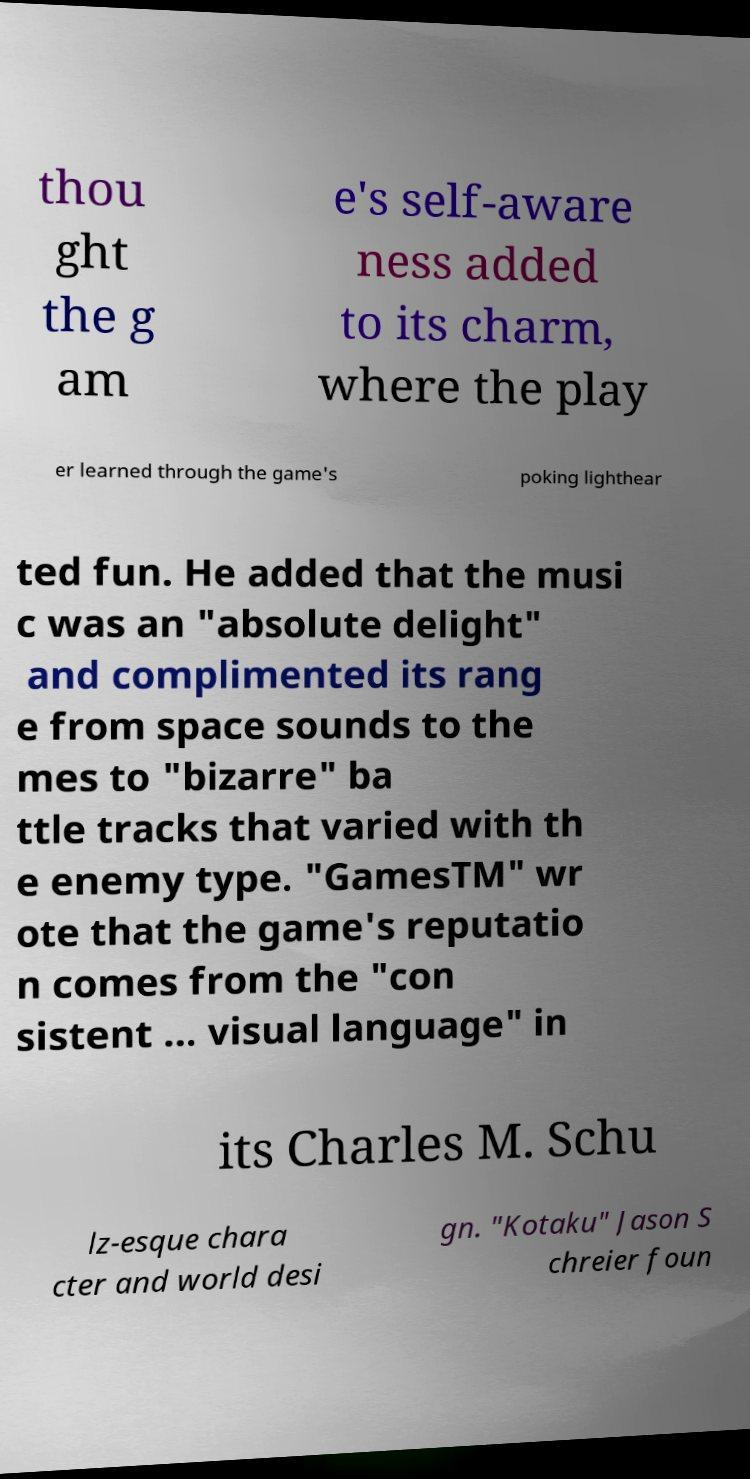Please read and relay the text visible in this image. What does it say? thou ght the g am e's self-aware ness added to its charm, where the play er learned through the game's poking lighthear ted fun. He added that the musi c was an "absolute delight" and complimented its rang e from space sounds to the mes to "bizarre" ba ttle tracks that varied with th e enemy type. "GamesTM" wr ote that the game's reputatio n comes from the "con sistent ... visual language" in its Charles M. Schu lz-esque chara cter and world desi gn. "Kotaku" Jason S chreier foun 